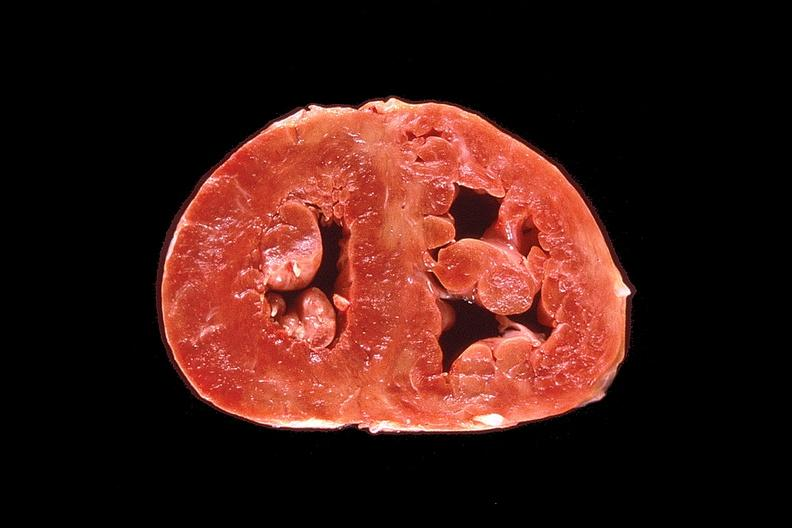what does this image show?
Answer the question using a single word or phrase. Heart 